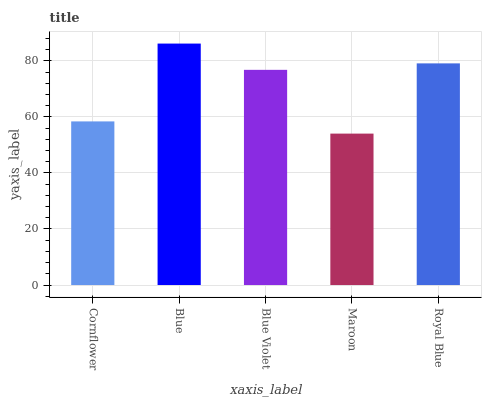Is Maroon the minimum?
Answer yes or no. Yes. Is Blue the maximum?
Answer yes or no. Yes. Is Blue Violet the minimum?
Answer yes or no. No. Is Blue Violet the maximum?
Answer yes or no. No. Is Blue greater than Blue Violet?
Answer yes or no. Yes. Is Blue Violet less than Blue?
Answer yes or no. Yes. Is Blue Violet greater than Blue?
Answer yes or no. No. Is Blue less than Blue Violet?
Answer yes or no. No. Is Blue Violet the high median?
Answer yes or no. Yes. Is Blue Violet the low median?
Answer yes or no. Yes. Is Blue the high median?
Answer yes or no. No. Is Royal Blue the low median?
Answer yes or no. No. 